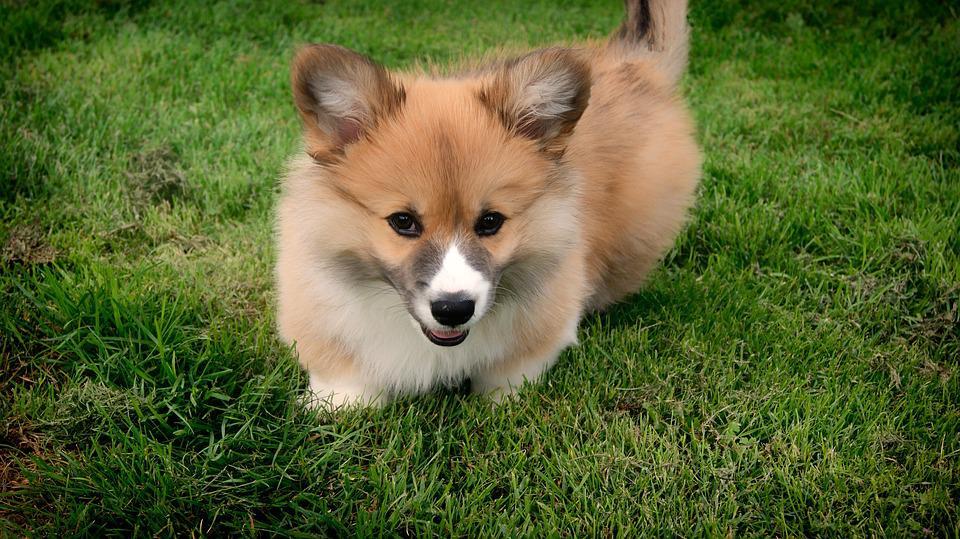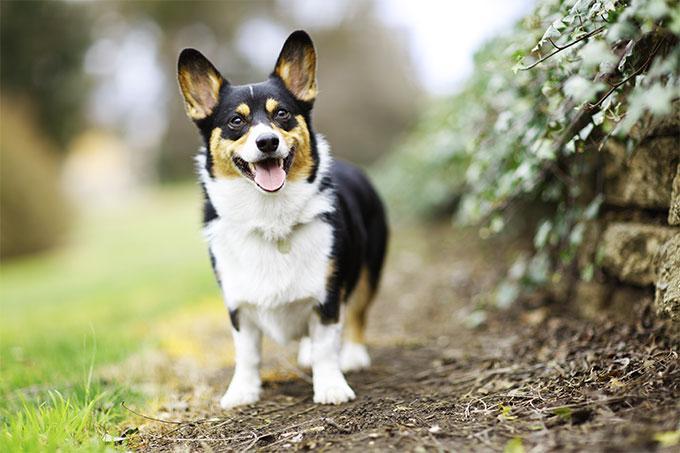The first image is the image on the left, the second image is the image on the right. Given the left and right images, does the statement "Two tan and white dogs have short legs and upright ears." hold true? Answer yes or no. No. 